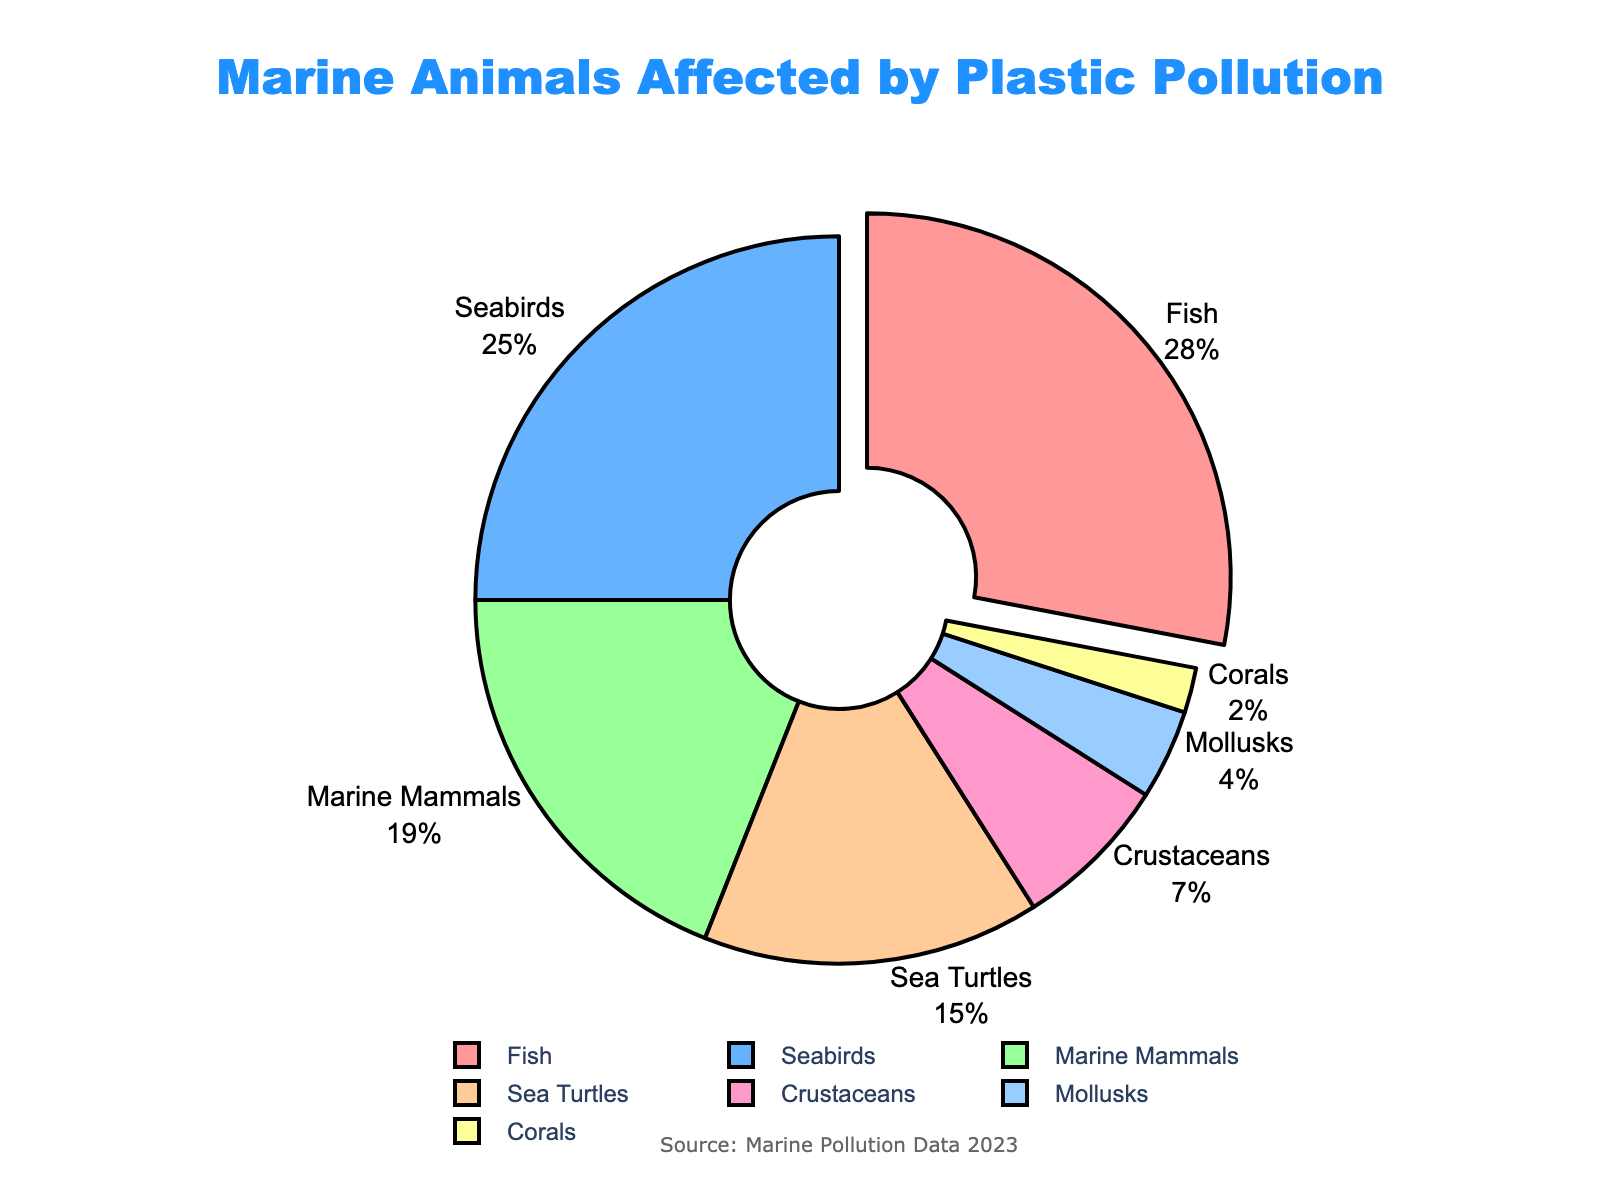What percentage of seabirds are affected by plastic pollution? Locate the segment labeled 'Seabirds' on the pie chart and read the percentage value associated with it.
Answer: 25% Which species group is most affected by plastic pollution? Identify the segment that is pulled out slightly from the rest of the pie chart and note its label and percentage.
Answer: Fish How much more are fish affected compared to crustaceans? Fish are labeled with 28%, and crustaceans with 7%. Subtract the crustacean percentage from the fish percentage: 28% - 7% = 21%.
Answer: 21% Is the combined percentage of marine mammals and sea turtles greater than that of seabirds? Add the percentages for marine mammals and sea turtles: 19% + 15% = 34%. Compare this sum to the seabirds' percentage (25%).
Answer: Yes, 34% > 25% Rank the species groups from most to least affected by plastic pollution. Observe each segment's label and corresponding percentage, then order them from highest to lowest percentage.
Answer: Fish, Seabirds, Marine Mammals, Sea Turtles, Crustaceans, Mollusks, Corals What is the total percentage affected by crustaceans, mollusks, and corals combined? Add the percentages for crustaceans (7%), mollusks (4%), and corals (2%): 7% + 4% + 2% = 13%.
Answer: 13% Which species group is least affected by plastic pollution? Identify the smallest segment on the pie chart and note its label and percentage.
Answer: Corals Are marine mammals or sea turtles more affected by plastic pollution, and by how much? Compare the percentages for marine mammals (19%) and sea turtles (15%). Subtract the lesser percentage from the greater: 19% - 15% = 4%.
Answer: Marine mammals by 4% Do seabirds and sea turtles combined comprise more than half the total affected? Add the percentages for seabirds (25%) and sea turtles (15%): 25% + 15% = 40%. Compare this sum to 50%.
Answer: No, 40% What percentage is represented by groups other than fish? Subtract the percentage of fish (28%) from 100%: 100% - 28% = 72%.
Answer: 72% 